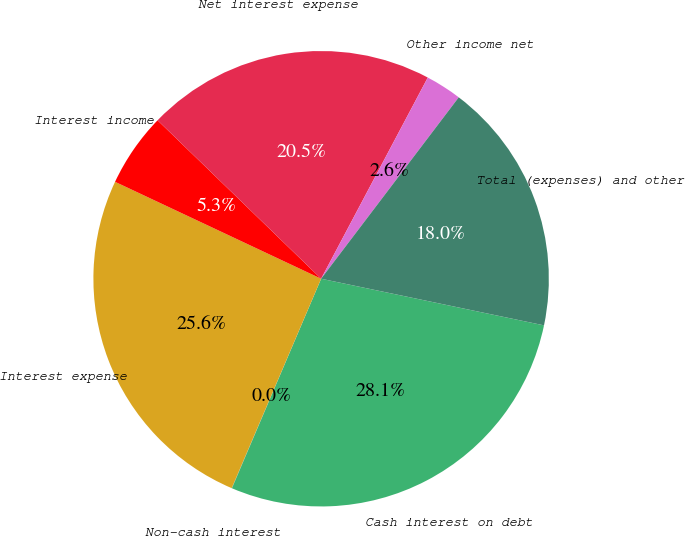<chart> <loc_0><loc_0><loc_500><loc_500><pie_chart><fcel>Cash interest on debt<fcel>Non-cash interest<fcel>Interest expense<fcel>Interest income<fcel>Net interest expense<fcel>Other income net<fcel>Total (expenses) and other<nl><fcel>28.12%<fcel>0.02%<fcel>25.57%<fcel>5.25%<fcel>20.51%<fcel>2.57%<fcel>17.95%<nl></chart> 